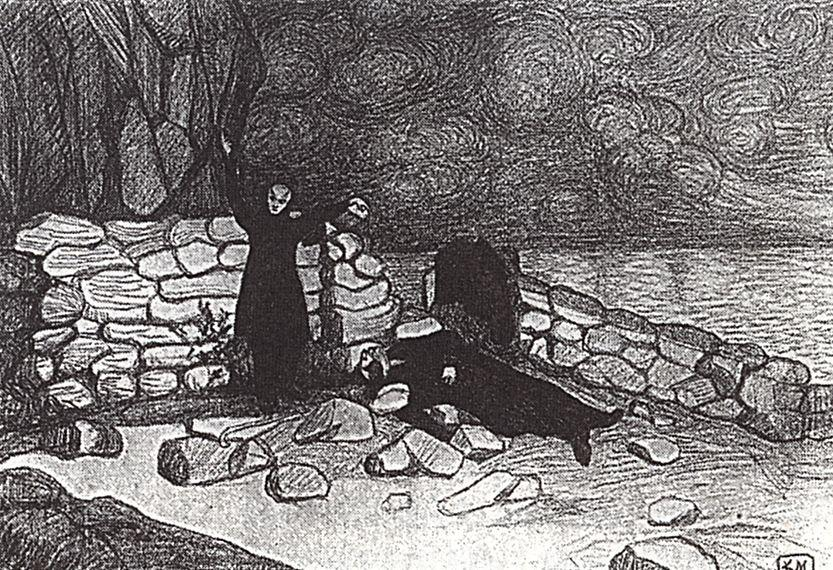What is this photo about? This image is a black and white sketch that captures a tranquil, yet slightly melancholic landscape. The art style leans towards impressionism, which emphasizes the emotional effect rather than meticulous detail. The focal points of the composition are a robust tree with branches stretching upward and an old stone building that adds a touch of mystery to the setting. Both elements are depicted in darker tones, contrasting vividly against the lighter sky full of swirling clouds, hinting at both stillness and motion. The setting on a rocky beach with scattered boulders further enhances the scene's rugged beauty, inviting viewers to ponder the stories that such a timeless landscape might hold, including themes of solitude, resilience, or even historical passages. 